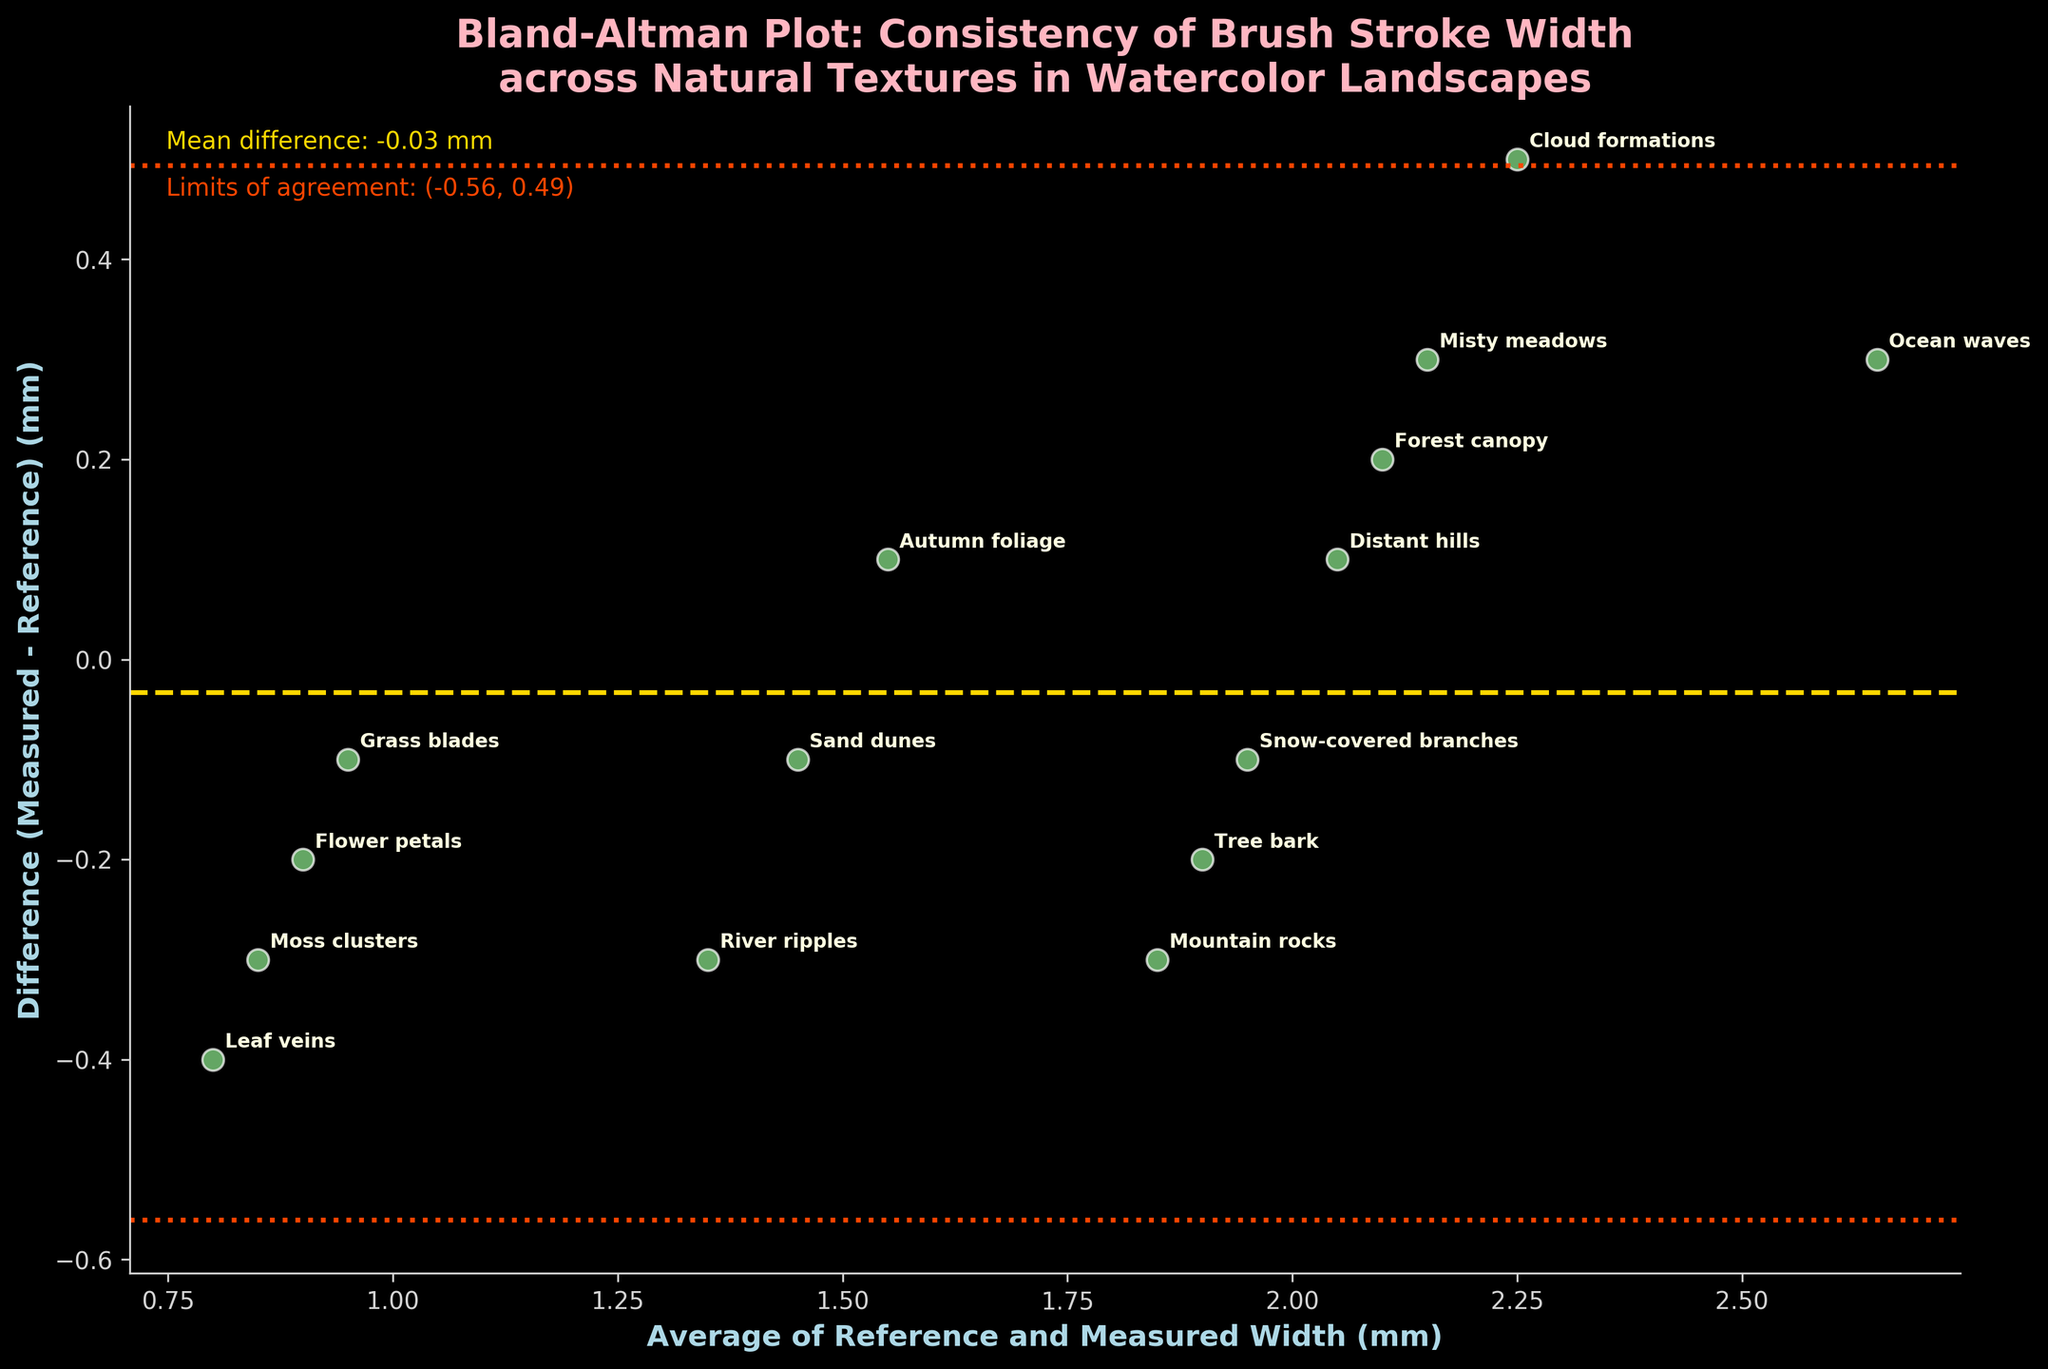What is the title of the plot? The title is displayed at the top center of the plot, written in light pink color.
Answer: Bland-Altman Plot: Consistency of Brush Stroke Width across Natural Textures in Watercolor Landscapes What is the range of the y-axis? By looking at the y-axis labels on the left side of the plot, we can see the numbers indicating the range.
Answer: -0.8 to 0.5 Where is the mean difference line located on the plot? The mean difference line is a horizontal dashed line colored gold, represented by the y-coordinate where it intersects the y-axis.
Answer: Around -0.16 mm What textures have the largest positive and negative differences from the reference width? By examining the points on the plot with the largest distances from the x-axis, we can identify the textures.
Answer: The largest positive difference is "Ocean waves" and the largest negative difference is "Leaf veins" Which texture is closest to the mean difference? The point closest to the gold dashed line indicates the smallest distance to the mean difference line.
Answer: Distant hills What are the limits of agreement? The limits of agreement are represented by the two horizontal dotted lines, one above and one below the mean difference line, and are annotated in the top left corner of the plot.
Answer: -0.75 mm and 0.43 mm How many textures fall outside the limits of agreement? Count the number of points that fall outside the two dotted lines on the plot.
Answer: Three textures Describe the overall consistency of brush stroke width as depicted in the plot. Assess the scatter of the data points relative to the mean difference line and the limits of agreement. The majority of the points are clustered around the mean difference with a few exceptions, indicating reasonable consistency with some outliers.
Answer: Reasonable consistency with some outliers What is the main visual difference between the points labeled "Tree bark" and "Sand dunes"? Compare the positions of the points corresponding to "Tree bark" and "Sand dunes" on the plot relative to the mean difference line. "Tree bark" is above the mean difference line and "Sand dunes" is below it, indicating different directions of differences from the reference width.
Answer: "Tree bark" is above the mean difference line and "Sand dunes" is below it 